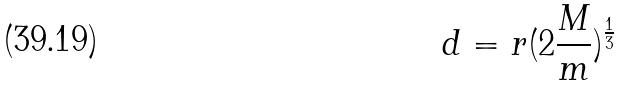Convert formula to latex. <formula><loc_0><loc_0><loc_500><loc_500>d = r ( 2 \frac { M } { m } ) ^ { \frac { 1 } { 3 } }</formula> 